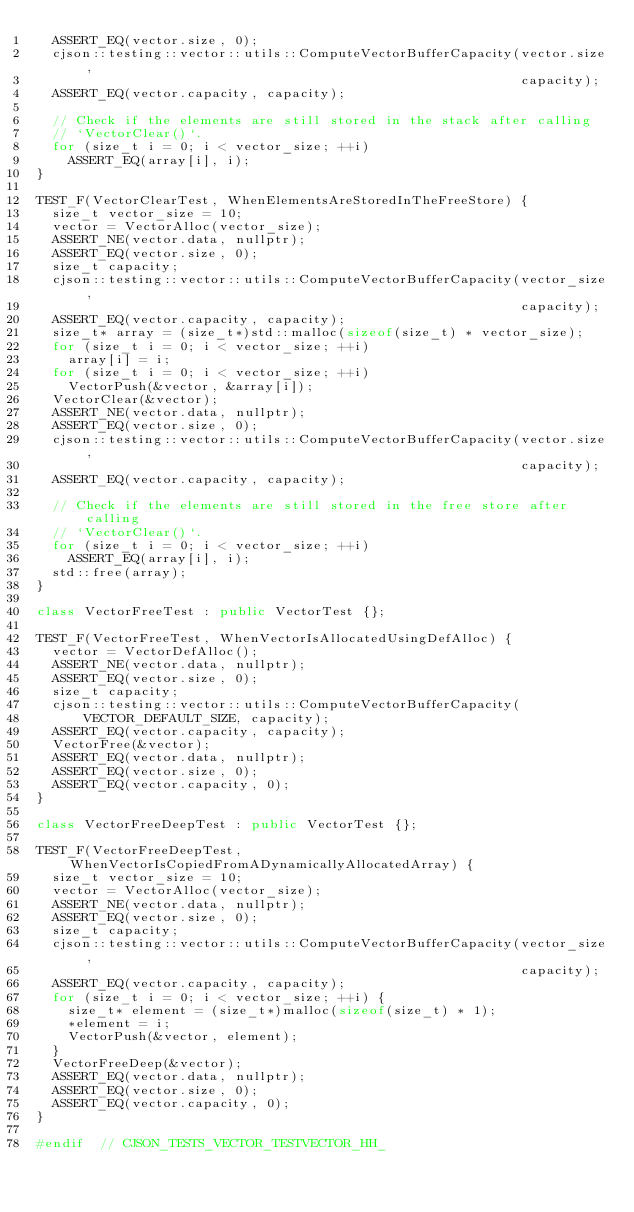Convert code to text. <code><loc_0><loc_0><loc_500><loc_500><_C++_>  ASSERT_EQ(vector.size, 0);
  cjson::testing::vector::utils::ComputeVectorBufferCapacity(vector.size,
                                                             capacity);
  ASSERT_EQ(vector.capacity, capacity);

  // Check if the elements are still stored in the stack after calling
  // `VectorClear()`.
  for (size_t i = 0; i < vector_size; ++i)
    ASSERT_EQ(array[i], i);
}

TEST_F(VectorClearTest, WhenElementsAreStoredInTheFreeStore) {
  size_t vector_size = 10;
  vector = VectorAlloc(vector_size);
  ASSERT_NE(vector.data, nullptr);
  ASSERT_EQ(vector.size, 0);
  size_t capacity;
  cjson::testing::vector::utils::ComputeVectorBufferCapacity(vector_size,
                                                             capacity);
  ASSERT_EQ(vector.capacity, capacity);
  size_t* array = (size_t*)std::malloc(sizeof(size_t) * vector_size);
  for (size_t i = 0; i < vector_size; ++i)
    array[i] = i;
  for (size_t i = 0; i < vector_size; ++i)
    VectorPush(&vector, &array[i]);
  VectorClear(&vector);
  ASSERT_NE(vector.data, nullptr);
  ASSERT_EQ(vector.size, 0);
  cjson::testing::vector::utils::ComputeVectorBufferCapacity(vector.size,
                                                             capacity);
  ASSERT_EQ(vector.capacity, capacity);

  // Check if the elements are still stored in the free store after calling
  // `VectorClear()`.
  for (size_t i = 0; i < vector_size; ++i)
    ASSERT_EQ(array[i], i);
  std::free(array);
}

class VectorFreeTest : public VectorTest {};

TEST_F(VectorFreeTest, WhenVectorIsAllocatedUsingDefAlloc) {
  vector = VectorDefAlloc();
  ASSERT_NE(vector.data, nullptr);
  ASSERT_EQ(vector.size, 0);
  size_t capacity;
  cjson::testing::vector::utils::ComputeVectorBufferCapacity(
      VECTOR_DEFAULT_SIZE, capacity);
  ASSERT_EQ(vector.capacity, capacity);
  VectorFree(&vector);
  ASSERT_EQ(vector.data, nullptr);
  ASSERT_EQ(vector.size, 0);
  ASSERT_EQ(vector.capacity, 0);
}

class VectorFreeDeepTest : public VectorTest {};

TEST_F(VectorFreeDeepTest, WhenVectorIsCopiedFromADynamicallyAllocatedArray) {
  size_t vector_size = 10;
  vector = VectorAlloc(vector_size);
  ASSERT_NE(vector.data, nullptr);
  ASSERT_EQ(vector.size, 0);
  size_t capacity;
  cjson::testing::vector::utils::ComputeVectorBufferCapacity(vector_size,
                                                             capacity);
  ASSERT_EQ(vector.capacity, capacity);
  for (size_t i = 0; i < vector_size; ++i) {
    size_t* element = (size_t*)malloc(sizeof(size_t) * 1);
    *element = i;
    VectorPush(&vector, element);
  }
  VectorFreeDeep(&vector);
  ASSERT_EQ(vector.data, nullptr);
  ASSERT_EQ(vector.size, 0);
  ASSERT_EQ(vector.capacity, 0);
}

#endif  // CJSON_TESTS_VECTOR_TESTVECTOR_HH_
</code> 